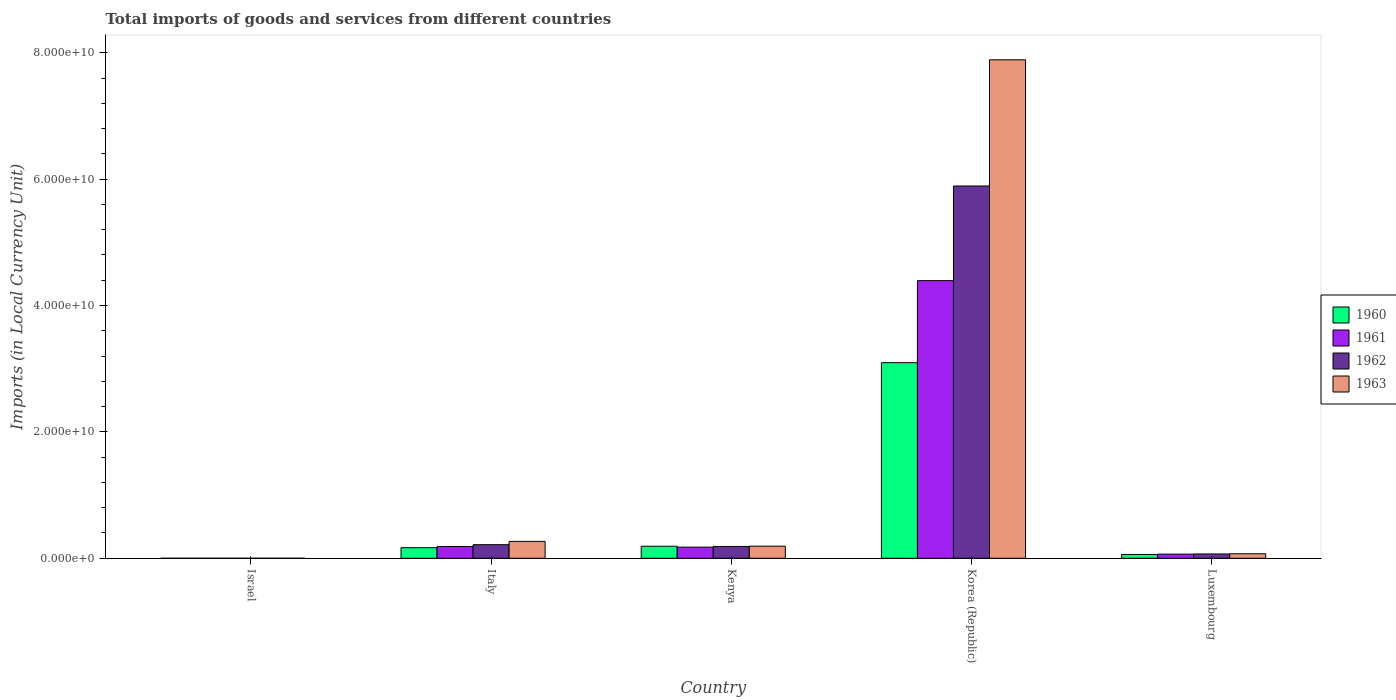How many different coloured bars are there?
Offer a terse response. 4. How many groups of bars are there?
Ensure brevity in your answer.  5. Are the number of bars on each tick of the X-axis equal?
Provide a succinct answer. Yes. How many bars are there on the 2nd tick from the left?
Give a very brief answer. 4. What is the label of the 1st group of bars from the left?
Provide a succinct answer. Israel. In how many cases, is the number of bars for a given country not equal to the number of legend labels?
Offer a terse response. 0. What is the Amount of goods and services imports in 1963 in Korea (Republic)?
Offer a very short reply. 7.89e+1. Across all countries, what is the maximum Amount of goods and services imports in 1961?
Offer a terse response. 4.39e+1. Across all countries, what is the minimum Amount of goods and services imports in 1962?
Give a very brief answer. 1.26e+05. What is the total Amount of goods and services imports in 1963 in the graph?
Keep it short and to the point. 8.42e+1. What is the difference between the Amount of goods and services imports in 1960 in Israel and that in Luxembourg?
Your answer should be compact. -6.02e+08. What is the difference between the Amount of goods and services imports in 1962 in Israel and the Amount of goods and services imports in 1960 in Kenya?
Your answer should be very brief. -1.90e+09. What is the average Amount of goods and services imports in 1960 per country?
Your response must be concise. 7.03e+09. What is the difference between the Amount of goods and services imports of/in 1960 and Amount of goods and services imports of/in 1961 in Luxembourg?
Give a very brief answer. -5.35e+07. In how many countries, is the Amount of goods and services imports in 1961 greater than 56000000000 LCU?
Give a very brief answer. 0. What is the ratio of the Amount of goods and services imports in 1963 in Israel to that in Italy?
Your response must be concise. 5.378096034779869e-5. Is the Amount of goods and services imports in 1963 in Israel less than that in Kenya?
Give a very brief answer. Yes. What is the difference between the highest and the second highest Amount of goods and services imports in 1960?
Offer a terse response. -2.93e+1. What is the difference between the highest and the lowest Amount of goods and services imports in 1961?
Make the answer very short. 4.39e+1. Is the sum of the Amount of goods and services imports in 1962 in Israel and Luxembourg greater than the maximum Amount of goods and services imports in 1963 across all countries?
Your answer should be very brief. No. What does the 2nd bar from the left in Italy represents?
Your answer should be very brief. 1961. What does the 3rd bar from the right in Luxembourg represents?
Provide a short and direct response. 1961. Is it the case that in every country, the sum of the Amount of goods and services imports in 1961 and Amount of goods and services imports in 1963 is greater than the Amount of goods and services imports in 1960?
Ensure brevity in your answer.  Yes. How many bars are there?
Give a very brief answer. 20. Are all the bars in the graph horizontal?
Provide a short and direct response. No. How many countries are there in the graph?
Provide a succinct answer. 5. Does the graph contain any zero values?
Provide a short and direct response. No. Where does the legend appear in the graph?
Ensure brevity in your answer.  Center right. How are the legend labels stacked?
Your response must be concise. Vertical. What is the title of the graph?
Ensure brevity in your answer.  Total imports of goods and services from different countries. What is the label or title of the X-axis?
Your response must be concise. Country. What is the label or title of the Y-axis?
Give a very brief answer. Imports (in Local Currency Unit). What is the Imports (in Local Currency Unit) of 1960 in Israel?
Provide a succinct answer. 5.78e+04. What is the Imports (in Local Currency Unit) in 1961 in Israel?
Your response must be concise. 7.04e+04. What is the Imports (in Local Currency Unit) in 1962 in Israel?
Offer a terse response. 1.26e+05. What is the Imports (in Local Currency Unit) in 1963 in Israel?
Ensure brevity in your answer.  1.44e+05. What is the Imports (in Local Currency Unit) in 1960 in Italy?
Your answer should be very brief. 1.67e+09. What is the Imports (in Local Currency Unit) of 1961 in Italy?
Your answer should be compact. 1.86e+09. What is the Imports (in Local Currency Unit) in 1962 in Italy?
Offer a very short reply. 2.15e+09. What is the Imports (in Local Currency Unit) in 1963 in Italy?
Provide a short and direct response. 2.67e+09. What is the Imports (in Local Currency Unit) of 1960 in Kenya?
Provide a succinct answer. 1.90e+09. What is the Imports (in Local Currency Unit) of 1961 in Kenya?
Provide a succinct answer. 1.76e+09. What is the Imports (in Local Currency Unit) in 1962 in Kenya?
Provide a short and direct response. 1.87e+09. What is the Imports (in Local Currency Unit) of 1963 in Kenya?
Provide a short and direct response. 1.92e+09. What is the Imports (in Local Currency Unit) in 1960 in Korea (Republic)?
Ensure brevity in your answer.  3.10e+1. What is the Imports (in Local Currency Unit) in 1961 in Korea (Republic)?
Offer a very short reply. 4.39e+1. What is the Imports (in Local Currency Unit) in 1962 in Korea (Republic)?
Your answer should be compact. 5.89e+1. What is the Imports (in Local Currency Unit) of 1963 in Korea (Republic)?
Provide a succinct answer. 7.89e+1. What is the Imports (in Local Currency Unit) of 1960 in Luxembourg?
Make the answer very short. 6.02e+08. What is the Imports (in Local Currency Unit) in 1961 in Luxembourg?
Your answer should be compact. 6.56e+08. What is the Imports (in Local Currency Unit) in 1962 in Luxembourg?
Make the answer very short. 6.82e+08. What is the Imports (in Local Currency Unit) of 1963 in Luxembourg?
Provide a succinct answer. 7.12e+08. Across all countries, what is the maximum Imports (in Local Currency Unit) of 1960?
Give a very brief answer. 3.10e+1. Across all countries, what is the maximum Imports (in Local Currency Unit) of 1961?
Make the answer very short. 4.39e+1. Across all countries, what is the maximum Imports (in Local Currency Unit) in 1962?
Keep it short and to the point. 5.89e+1. Across all countries, what is the maximum Imports (in Local Currency Unit) of 1963?
Ensure brevity in your answer.  7.89e+1. Across all countries, what is the minimum Imports (in Local Currency Unit) of 1960?
Offer a very short reply. 5.78e+04. Across all countries, what is the minimum Imports (in Local Currency Unit) in 1961?
Keep it short and to the point. 7.04e+04. Across all countries, what is the minimum Imports (in Local Currency Unit) in 1962?
Keep it short and to the point. 1.26e+05. Across all countries, what is the minimum Imports (in Local Currency Unit) of 1963?
Provide a short and direct response. 1.44e+05. What is the total Imports (in Local Currency Unit) in 1960 in the graph?
Your answer should be very brief. 3.51e+1. What is the total Imports (in Local Currency Unit) in 1961 in the graph?
Give a very brief answer. 4.82e+1. What is the total Imports (in Local Currency Unit) of 1962 in the graph?
Your answer should be very brief. 6.36e+1. What is the total Imports (in Local Currency Unit) of 1963 in the graph?
Make the answer very short. 8.42e+1. What is the difference between the Imports (in Local Currency Unit) of 1960 in Israel and that in Italy?
Your response must be concise. -1.67e+09. What is the difference between the Imports (in Local Currency Unit) in 1961 in Israel and that in Italy?
Your answer should be very brief. -1.86e+09. What is the difference between the Imports (in Local Currency Unit) of 1962 in Israel and that in Italy?
Give a very brief answer. -2.15e+09. What is the difference between the Imports (in Local Currency Unit) of 1963 in Israel and that in Italy?
Offer a terse response. -2.67e+09. What is the difference between the Imports (in Local Currency Unit) of 1960 in Israel and that in Kenya?
Offer a terse response. -1.90e+09. What is the difference between the Imports (in Local Currency Unit) of 1961 in Israel and that in Kenya?
Provide a succinct answer. -1.76e+09. What is the difference between the Imports (in Local Currency Unit) in 1962 in Israel and that in Kenya?
Offer a very short reply. -1.87e+09. What is the difference between the Imports (in Local Currency Unit) of 1963 in Israel and that in Kenya?
Provide a short and direct response. -1.92e+09. What is the difference between the Imports (in Local Currency Unit) in 1960 in Israel and that in Korea (Republic)?
Give a very brief answer. -3.10e+1. What is the difference between the Imports (in Local Currency Unit) of 1961 in Israel and that in Korea (Republic)?
Your answer should be compact. -4.39e+1. What is the difference between the Imports (in Local Currency Unit) of 1962 in Israel and that in Korea (Republic)?
Your response must be concise. -5.89e+1. What is the difference between the Imports (in Local Currency Unit) of 1963 in Israel and that in Korea (Republic)?
Keep it short and to the point. -7.89e+1. What is the difference between the Imports (in Local Currency Unit) in 1960 in Israel and that in Luxembourg?
Your response must be concise. -6.02e+08. What is the difference between the Imports (in Local Currency Unit) of 1961 in Israel and that in Luxembourg?
Give a very brief answer. -6.56e+08. What is the difference between the Imports (in Local Currency Unit) in 1962 in Israel and that in Luxembourg?
Give a very brief answer. -6.82e+08. What is the difference between the Imports (in Local Currency Unit) in 1963 in Israel and that in Luxembourg?
Offer a terse response. -7.12e+08. What is the difference between the Imports (in Local Currency Unit) in 1960 in Italy and that in Kenya?
Offer a very short reply. -2.29e+08. What is the difference between the Imports (in Local Currency Unit) in 1961 in Italy and that in Kenya?
Make the answer very short. 9.87e+07. What is the difference between the Imports (in Local Currency Unit) of 1962 in Italy and that in Kenya?
Your answer should be compact. 2.80e+08. What is the difference between the Imports (in Local Currency Unit) of 1963 in Italy and that in Kenya?
Keep it short and to the point. 7.55e+08. What is the difference between the Imports (in Local Currency Unit) in 1960 in Italy and that in Korea (Republic)?
Provide a succinct answer. -2.93e+1. What is the difference between the Imports (in Local Currency Unit) in 1961 in Italy and that in Korea (Republic)?
Keep it short and to the point. -4.21e+1. What is the difference between the Imports (in Local Currency Unit) of 1962 in Italy and that in Korea (Republic)?
Your response must be concise. -5.68e+1. What is the difference between the Imports (in Local Currency Unit) in 1963 in Italy and that in Korea (Republic)?
Your response must be concise. -7.62e+1. What is the difference between the Imports (in Local Currency Unit) of 1960 in Italy and that in Luxembourg?
Ensure brevity in your answer.  1.07e+09. What is the difference between the Imports (in Local Currency Unit) of 1961 in Italy and that in Luxembourg?
Give a very brief answer. 1.21e+09. What is the difference between the Imports (in Local Currency Unit) of 1962 in Italy and that in Luxembourg?
Your response must be concise. 1.47e+09. What is the difference between the Imports (in Local Currency Unit) of 1963 in Italy and that in Luxembourg?
Ensure brevity in your answer.  1.96e+09. What is the difference between the Imports (in Local Currency Unit) in 1960 in Kenya and that in Korea (Republic)?
Ensure brevity in your answer.  -2.91e+1. What is the difference between the Imports (in Local Currency Unit) in 1961 in Kenya and that in Korea (Republic)?
Your response must be concise. -4.22e+1. What is the difference between the Imports (in Local Currency Unit) of 1962 in Kenya and that in Korea (Republic)?
Keep it short and to the point. -5.70e+1. What is the difference between the Imports (in Local Currency Unit) of 1963 in Kenya and that in Korea (Republic)?
Ensure brevity in your answer.  -7.70e+1. What is the difference between the Imports (in Local Currency Unit) in 1960 in Kenya and that in Luxembourg?
Your response must be concise. 1.30e+09. What is the difference between the Imports (in Local Currency Unit) in 1961 in Kenya and that in Luxembourg?
Keep it short and to the point. 1.11e+09. What is the difference between the Imports (in Local Currency Unit) of 1962 in Kenya and that in Luxembourg?
Offer a very short reply. 1.19e+09. What is the difference between the Imports (in Local Currency Unit) in 1963 in Kenya and that in Luxembourg?
Keep it short and to the point. 1.21e+09. What is the difference between the Imports (in Local Currency Unit) of 1960 in Korea (Republic) and that in Luxembourg?
Ensure brevity in your answer.  3.04e+1. What is the difference between the Imports (in Local Currency Unit) in 1961 in Korea (Republic) and that in Luxembourg?
Keep it short and to the point. 4.33e+1. What is the difference between the Imports (in Local Currency Unit) of 1962 in Korea (Republic) and that in Luxembourg?
Keep it short and to the point. 5.82e+1. What is the difference between the Imports (in Local Currency Unit) in 1963 in Korea (Republic) and that in Luxembourg?
Ensure brevity in your answer.  7.82e+1. What is the difference between the Imports (in Local Currency Unit) of 1960 in Israel and the Imports (in Local Currency Unit) of 1961 in Italy?
Keep it short and to the point. -1.86e+09. What is the difference between the Imports (in Local Currency Unit) of 1960 in Israel and the Imports (in Local Currency Unit) of 1962 in Italy?
Offer a terse response. -2.15e+09. What is the difference between the Imports (in Local Currency Unit) in 1960 in Israel and the Imports (in Local Currency Unit) in 1963 in Italy?
Provide a succinct answer. -2.67e+09. What is the difference between the Imports (in Local Currency Unit) in 1961 in Israel and the Imports (in Local Currency Unit) in 1962 in Italy?
Give a very brief answer. -2.15e+09. What is the difference between the Imports (in Local Currency Unit) in 1961 in Israel and the Imports (in Local Currency Unit) in 1963 in Italy?
Give a very brief answer. -2.67e+09. What is the difference between the Imports (in Local Currency Unit) of 1962 in Israel and the Imports (in Local Currency Unit) of 1963 in Italy?
Make the answer very short. -2.67e+09. What is the difference between the Imports (in Local Currency Unit) in 1960 in Israel and the Imports (in Local Currency Unit) in 1961 in Kenya?
Your answer should be compact. -1.76e+09. What is the difference between the Imports (in Local Currency Unit) of 1960 in Israel and the Imports (in Local Currency Unit) of 1962 in Kenya?
Ensure brevity in your answer.  -1.87e+09. What is the difference between the Imports (in Local Currency Unit) of 1960 in Israel and the Imports (in Local Currency Unit) of 1963 in Kenya?
Ensure brevity in your answer.  -1.92e+09. What is the difference between the Imports (in Local Currency Unit) of 1961 in Israel and the Imports (in Local Currency Unit) of 1962 in Kenya?
Keep it short and to the point. -1.87e+09. What is the difference between the Imports (in Local Currency Unit) in 1961 in Israel and the Imports (in Local Currency Unit) in 1963 in Kenya?
Offer a terse response. -1.92e+09. What is the difference between the Imports (in Local Currency Unit) in 1962 in Israel and the Imports (in Local Currency Unit) in 1963 in Kenya?
Offer a very short reply. -1.92e+09. What is the difference between the Imports (in Local Currency Unit) in 1960 in Israel and the Imports (in Local Currency Unit) in 1961 in Korea (Republic)?
Provide a succinct answer. -4.39e+1. What is the difference between the Imports (in Local Currency Unit) of 1960 in Israel and the Imports (in Local Currency Unit) of 1962 in Korea (Republic)?
Offer a terse response. -5.89e+1. What is the difference between the Imports (in Local Currency Unit) in 1960 in Israel and the Imports (in Local Currency Unit) in 1963 in Korea (Republic)?
Give a very brief answer. -7.89e+1. What is the difference between the Imports (in Local Currency Unit) of 1961 in Israel and the Imports (in Local Currency Unit) of 1962 in Korea (Republic)?
Ensure brevity in your answer.  -5.89e+1. What is the difference between the Imports (in Local Currency Unit) of 1961 in Israel and the Imports (in Local Currency Unit) of 1963 in Korea (Republic)?
Make the answer very short. -7.89e+1. What is the difference between the Imports (in Local Currency Unit) in 1962 in Israel and the Imports (in Local Currency Unit) in 1963 in Korea (Republic)?
Keep it short and to the point. -7.89e+1. What is the difference between the Imports (in Local Currency Unit) in 1960 in Israel and the Imports (in Local Currency Unit) in 1961 in Luxembourg?
Make the answer very short. -6.56e+08. What is the difference between the Imports (in Local Currency Unit) of 1960 in Israel and the Imports (in Local Currency Unit) of 1962 in Luxembourg?
Your answer should be compact. -6.82e+08. What is the difference between the Imports (in Local Currency Unit) in 1960 in Israel and the Imports (in Local Currency Unit) in 1963 in Luxembourg?
Ensure brevity in your answer.  -7.12e+08. What is the difference between the Imports (in Local Currency Unit) of 1961 in Israel and the Imports (in Local Currency Unit) of 1962 in Luxembourg?
Your answer should be compact. -6.82e+08. What is the difference between the Imports (in Local Currency Unit) in 1961 in Israel and the Imports (in Local Currency Unit) in 1963 in Luxembourg?
Keep it short and to the point. -7.12e+08. What is the difference between the Imports (in Local Currency Unit) in 1962 in Israel and the Imports (in Local Currency Unit) in 1963 in Luxembourg?
Your answer should be very brief. -7.12e+08. What is the difference between the Imports (in Local Currency Unit) of 1960 in Italy and the Imports (in Local Currency Unit) of 1961 in Kenya?
Your response must be concise. -8.91e+07. What is the difference between the Imports (in Local Currency Unit) in 1960 in Italy and the Imports (in Local Currency Unit) in 1962 in Kenya?
Offer a terse response. -1.94e+08. What is the difference between the Imports (in Local Currency Unit) in 1960 in Italy and the Imports (in Local Currency Unit) in 1963 in Kenya?
Give a very brief answer. -2.43e+08. What is the difference between the Imports (in Local Currency Unit) in 1961 in Italy and the Imports (in Local Currency Unit) in 1962 in Kenya?
Give a very brief answer. -6.13e+06. What is the difference between the Imports (in Local Currency Unit) in 1961 in Italy and the Imports (in Local Currency Unit) in 1963 in Kenya?
Your response must be concise. -5.50e+07. What is the difference between the Imports (in Local Currency Unit) of 1962 in Italy and the Imports (in Local Currency Unit) of 1963 in Kenya?
Offer a very short reply. 2.31e+08. What is the difference between the Imports (in Local Currency Unit) in 1960 in Italy and the Imports (in Local Currency Unit) in 1961 in Korea (Republic)?
Your response must be concise. -4.23e+1. What is the difference between the Imports (in Local Currency Unit) of 1960 in Italy and the Imports (in Local Currency Unit) of 1962 in Korea (Republic)?
Offer a terse response. -5.72e+1. What is the difference between the Imports (in Local Currency Unit) in 1960 in Italy and the Imports (in Local Currency Unit) in 1963 in Korea (Republic)?
Keep it short and to the point. -7.72e+1. What is the difference between the Imports (in Local Currency Unit) of 1961 in Italy and the Imports (in Local Currency Unit) of 1962 in Korea (Republic)?
Make the answer very short. -5.71e+1. What is the difference between the Imports (in Local Currency Unit) in 1961 in Italy and the Imports (in Local Currency Unit) in 1963 in Korea (Republic)?
Provide a short and direct response. -7.70e+1. What is the difference between the Imports (in Local Currency Unit) in 1962 in Italy and the Imports (in Local Currency Unit) in 1963 in Korea (Republic)?
Ensure brevity in your answer.  -7.67e+1. What is the difference between the Imports (in Local Currency Unit) of 1960 in Italy and the Imports (in Local Currency Unit) of 1961 in Luxembourg?
Ensure brevity in your answer.  1.02e+09. What is the difference between the Imports (in Local Currency Unit) in 1960 in Italy and the Imports (in Local Currency Unit) in 1962 in Luxembourg?
Offer a terse response. 9.92e+08. What is the difference between the Imports (in Local Currency Unit) in 1960 in Italy and the Imports (in Local Currency Unit) in 1963 in Luxembourg?
Offer a very short reply. 9.62e+08. What is the difference between the Imports (in Local Currency Unit) of 1961 in Italy and the Imports (in Local Currency Unit) of 1962 in Luxembourg?
Make the answer very short. 1.18e+09. What is the difference between the Imports (in Local Currency Unit) of 1961 in Italy and the Imports (in Local Currency Unit) of 1963 in Luxembourg?
Offer a very short reply. 1.15e+09. What is the difference between the Imports (in Local Currency Unit) of 1962 in Italy and the Imports (in Local Currency Unit) of 1963 in Luxembourg?
Give a very brief answer. 1.44e+09. What is the difference between the Imports (in Local Currency Unit) of 1960 in Kenya and the Imports (in Local Currency Unit) of 1961 in Korea (Republic)?
Your response must be concise. -4.20e+1. What is the difference between the Imports (in Local Currency Unit) of 1960 in Kenya and the Imports (in Local Currency Unit) of 1962 in Korea (Republic)?
Ensure brevity in your answer.  -5.70e+1. What is the difference between the Imports (in Local Currency Unit) of 1960 in Kenya and the Imports (in Local Currency Unit) of 1963 in Korea (Republic)?
Give a very brief answer. -7.70e+1. What is the difference between the Imports (in Local Currency Unit) of 1961 in Kenya and the Imports (in Local Currency Unit) of 1962 in Korea (Republic)?
Provide a succinct answer. -5.71e+1. What is the difference between the Imports (in Local Currency Unit) of 1961 in Kenya and the Imports (in Local Currency Unit) of 1963 in Korea (Republic)?
Keep it short and to the point. -7.71e+1. What is the difference between the Imports (in Local Currency Unit) of 1962 in Kenya and the Imports (in Local Currency Unit) of 1963 in Korea (Republic)?
Your answer should be compact. -7.70e+1. What is the difference between the Imports (in Local Currency Unit) of 1960 in Kenya and the Imports (in Local Currency Unit) of 1961 in Luxembourg?
Provide a short and direct response. 1.25e+09. What is the difference between the Imports (in Local Currency Unit) in 1960 in Kenya and the Imports (in Local Currency Unit) in 1962 in Luxembourg?
Give a very brief answer. 1.22e+09. What is the difference between the Imports (in Local Currency Unit) of 1960 in Kenya and the Imports (in Local Currency Unit) of 1963 in Luxembourg?
Make the answer very short. 1.19e+09. What is the difference between the Imports (in Local Currency Unit) in 1961 in Kenya and the Imports (in Local Currency Unit) in 1962 in Luxembourg?
Offer a very short reply. 1.08e+09. What is the difference between the Imports (in Local Currency Unit) in 1961 in Kenya and the Imports (in Local Currency Unit) in 1963 in Luxembourg?
Your response must be concise. 1.05e+09. What is the difference between the Imports (in Local Currency Unit) in 1962 in Kenya and the Imports (in Local Currency Unit) in 1963 in Luxembourg?
Give a very brief answer. 1.16e+09. What is the difference between the Imports (in Local Currency Unit) of 1960 in Korea (Republic) and the Imports (in Local Currency Unit) of 1961 in Luxembourg?
Your answer should be very brief. 3.03e+1. What is the difference between the Imports (in Local Currency Unit) in 1960 in Korea (Republic) and the Imports (in Local Currency Unit) in 1962 in Luxembourg?
Make the answer very short. 3.03e+1. What is the difference between the Imports (in Local Currency Unit) of 1960 in Korea (Republic) and the Imports (in Local Currency Unit) of 1963 in Luxembourg?
Make the answer very short. 3.02e+1. What is the difference between the Imports (in Local Currency Unit) in 1961 in Korea (Republic) and the Imports (in Local Currency Unit) in 1962 in Luxembourg?
Provide a short and direct response. 4.33e+1. What is the difference between the Imports (in Local Currency Unit) in 1961 in Korea (Republic) and the Imports (in Local Currency Unit) in 1963 in Luxembourg?
Give a very brief answer. 4.32e+1. What is the difference between the Imports (in Local Currency Unit) in 1962 in Korea (Republic) and the Imports (in Local Currency Unit) in 1963 in Luxembourg?
Provide a short and direct response. 5.82e+1. What is the average Imports (in Local Currency Unit) in 1960 per country?
Your response must be concise. 7.03e+09. What is the average Imports (in Local Currency Unit) in 1961 per country?
Ensure brevity in your answer.  9.64e+09. What is the average Imports (in Local Currency Unit) in 1962 per country?
Give a very brief answer. 1.27e+1. What is the average Imports (in Local Currency Unit) in 1963 per country?
Provide a succinct answer. 1.68e+1. What is the difference between the Imports (in Local Currency Unit) in 1960 and Imports (in Local Currency Unit) in 1961 in Israel?
Your response must be concise. -1.26e+04. What is the difference between the Imports (in Local Currency Unit) of 1960 and Imports (in Local Currency Unit) of 1962 in Israel?
Offer a very short reply. -6.82e+04. What is the difference between the Imports (in Local Currency Unit) of 1960 and Imports (in Local Currency Unit) of 1963 in Israel?
Your answer should be compact. -8.59e+04. What is the difference between the Imports (in Local Currency Unit) in 1961 and Imports (in Local Currency Unit) in 1962 in Israel?
Offer a terse response. -5.56e+04. What is the difference between the Imports (in Local Currency Unit) in 1961 and Imports (in Local Currency Unit) in 1963 in Israel?
Provide a short and direct response. -7.33e+04. What is the difference between the Imports (in Local Currency Unit) of 1962 and Imports (in Local Currency Unit) of 1963 in Israel?
Your answer should be very brief. -1.77e+04. What is the difference between the Imports (in Local Currency Unit) in 1960 and Imports (in Local Currency Unit) in 1961 in Italy?
Provide a succinct answer. -1.88e+08. What is the difference between the Imports (in Local Currency Unit) in 1960 and Imports (in Local Currency Unit) in 1962 in Italy?
Ensure brevity in your answer.  -4.73e+08. What is the difference between the Imports (in Local Currency Unit) in 1960 and Imports (in Local Currency Unit) in 1963 in Italy?
Your answer should be very brief. -9.98e+08. What is the difference between the Imports (in Local Currency Unit) in 1961 and Imports (in Local Currency Unit) in 1962 in Italy?
Ensure brevity in your answer.  -2.86e+08. What is the difference between the Imports (in Local Currency Unit) of 1961 and Imports (in Local Currency Unit) of 1963 in Italy?
Give a very brief answer. -8.10e+08. What is the difference between the Imports (in Local Currency Unit) in 1962 and Imports (in Local Currency Unit) in 1963 in Italy?
Your answer should be compact. -5.24e+08. What is the difference between the Imports (in Local Currency Unit) of 1960 and Imports (in Local Currency Unit) of 1961 in Kenya?
Your answer should be very brief. 1.40e+08. What is the difference between the Imports (in Local Currency Unit) of 1960 and Imports (in Local Currency Unit) of 1962 in Kenya?
Ensure brevity in your answer.  3.50e+07. What is the difference between the Imports (in Local Currency Unit) of 1960 and Imports (in Local Currency Unit) of 1963 in Kenya?
Offer a very short reply. -1.39e+07. What is the difference between the Imports (in Local Currency Unit) in 1961 and Imports (in Local Currency Unit) in 1962 in Kenya?
Your answer should be very brief. -1.05e+08. What is the difference between the Imports (in Local Currency Unit) in 1961 and Imports (in Local Currency Unit) in 1963 in Kenya?
Your response must be concise. -1.54e+08. What is the difference between the Imports (in Local Currency Unit) of 1962 and Imports (in Local Currency Unit) of 1963 in Kenya?
Provide a succinct answer. -4.89e+07. What is the difference between the Imports (in Local Currency Unit) in 1960 and Imports (in Local Currency Unit) in 1961 in Korea (Republic)?
Provide a succinct answer. -1.30e+1. What is the difference between the Imports (in Local Currency Unit) in 1960 and Imports (in Local Currency Unit) in 1962 in Korea (Republic)?
Offer a terse response. -2.80e+1. What is the difference between the Imports (in Local Currency Unit) in 1960 and Imports (in Local Currency Unit) in 1963 in Korea (Republic)?
Keep it short and to the point. -4.79e+1. What is the difference between the Imports (in Local Currency Unit) of 1961 and Imports (in Local Currency Unit) of 1962 in Korea (Republic)?
Offer a terse response. -1.50e+1. What is the difference between the Imports (in Local Currency Unit) in 1961 and Imports (in Local Currency Unit) in 1963 in Korea (Republic)?
Give a very brief answer. -3.49e+1. What is the difference between the Imports (in Local Currency Unit) of 1962 and Imports (in Local Currency Unit) of 1963 in Korea (Republic)?
Offer a terse response. -2.00e+1. What is the difference between the Imports (in Local Currency Unit) of 1960 and Imports (in Local Currency Unit) of 1961 in Luxembourg?
Provide a succinct answer. -5.35e+07. What is the difference between the Imports (in Local Currency Unit) in 1960 and Imports (in Local Currency Unit) in 1962 in Luxembourg?
Provide a short and direct response. -7.95e+07. What is the difference between the Imports (in Local Currency Unit) of 1960 and Imports (in Local Currency Unit) of 1963 in Luxembourg?
Offer a terse response. -1.09e+08. What is the difference between the Imports (in Local Currency Unit) in 1961 and Imports (in Local Currency Unit) in 1962 in Luxembourg?
Provide a succinct answer. -2.61e+07. What is the difference between the Imports (in Local Currency Unit) of 1961 and Imports (in Local Currency Unit) of 1963 in Luxembourg?
Your answer should be very brief. -5.59e+07. What is the difference between the Imports (in Local Currency Unit) in 1962 and Imports (in Local Currency Unit) in 1963 in Luxembourg?
Ensure brevity in your answer.  -2.99e+07. What is the ratio of the Imports (in Local Currency Unit) in 1961 in Israel to that in Italy?
Offer a terse response. 0. What is the ratio of the Imports (in Local Currency Unit) in 1963 in Israel to that in Italy?
Ensure brevity in your answer.  0. What is the ratio of the Imports (in Local Currency Unit) of 1960 in Israel to that in Kenya?
Ensure brevity in your answer.  0. What is the ratio of the Imports (in Local Currency Unit) of 1962 in Israel to that in Kenya?
Provide a succinct answer. 0. What is the ratio of the Imports (in Local Currency Unit) in 1960 in Israel to that in Korea (Republic)?
Give a very brief answer. 0. What is the ratio of the Imports (in Local Currency Unit) of 1963 in Israel to that in Korea (Republic)?
Your response must be concise. 0. What is the ratio of the Imports (in Local Currency Unit) of 1963 in Israel to that in Luxembourg?
Provide a short and direct response. 0. What is the ratio of the Imports (in Local Currency Unit) in 1960 in Italy to that in Kenya?
Your response must be concise. 0.88. What is the ratio of the Imports (in Local Currency Unit) of 1961 in Italy to that in Kenya?
Provide a short and direct response. 1.06. What is the ratio of the Imports (in Local Currency Unit) of 1962 in Italy to that in Kenya?
Keep it short and to the point. 1.15. What is the ratio of the Imports (in Local Currency Unit) of 1963 in Italy to that in Kenya?
Your answer should be very brief. 1.39. What is the ratio of the Imports (in Local Currency Unit) in 1960 in Italy to that in Korea (Republic)?
Offer a very short reply. 0.05. What is the ratio of the Imports (in Local Currency Unit) of 1961 in Italy to that in Korea (Republic)?
Provide a short and direct response. 0.04. What is the ratio of the Imports (in Local Currency Unit) of 1962 in Italy to that in Korea (Republic)?
Ensure brevity in your answer.  0.04. What is the ratio of the Imports (in Local Currency Unit) of 1963 in Italy to that in Korea (Republic)?
Offer a very short reply. 0.03. What is the ratio of the Imports (in Local Currency Unit) of 1960 in Italy to that in Luxembourg?
Provide a succinct answer. 2.78. What is the ratio of the Imports (in Local Currency Unit) in 1961 in Italy to that in Luxembourg?
Your answer should be very brief. 2.84. What is the ratio of the Imports (in Local Currency Unit) in 1962 in Italy to that in Luxembourg?
Provide a succinct answer. 3.15. What is the ratio of the Imports (in Local Currency Unit) in 1963 in Italy to that in Luxembourg?
Ensure brevity in your answer.  3.75. What is the ratio of the Imports (in Local Currency Unit) of 1960 in Kenya to that in Korea (Republic)?
Offer a terse response. 0.06. What is the ratio of the Imports (in Local Currency Unit) of 1961 in Kenya to that in Korea (Republic)?
Make the answer very short. 0.04. What is the ratio of the Imports (in Local Currency Unit) in 1962 in Kenya to that in Korea (Republic)?
Offer a terse response. 0.03. What is the ratio of the Imports (in Local Currency Unit) in 1963 in Kenya to that in Korea (Republic)?
Make the answer very short. 0.02. What is the ratio of the Imports (in Local Currency Unit) in 1960 in Kenya to that in Luxembourg?
Give a very brief answer. 3.16. What is the ratio of the Imports (in Local Currency Unit) in 1961 in Kenya to that in Luxembourg?
Your response must be concise. 2.69. What is the ratio of the Imports (in Local Currency Unit) in 1962 in Kenya to that in Luxembourg?
Provide a short and direct response. 2.74. What is the ratio of the Imports (in Local Currency Unit) in 1963 in Kenya to that in Luxembourg?
Offer a terse response. 2.69. What is the ratio of the Imports (in Local Currency Unit) of 1960 in Korea (Republic) to that in Luxembourg?
Your response must be concise. 51.39. What is the ratio of the Imports (in Local Currency Unit) in 1961 in Korea (Republic) to that in Luxembourg?
Give a very brief answer. 66.99. What is the ratio of the Imports (in Local Currency Unit) in 1962 in Korea (Republic) to that in Luxembourg?
Make the answer very short. 86.4. What is the ratio of the Imports (in Local Currency Unit) in 1963 in Korea (Republic) to that in Luxembourg?
Your response must be concise. 110.83. What is the difference between the highest and the second highest Imports (in Local Currency Unit) of 1960?
Keep it short and to the point. 2.91e+1. What is the difference between the highest and the second highest Imports (in Local Currency Unit) of 1961?
Ensure brevity in your answer.  4.21e+1. What is the difference between the highest and the second highest Imports (in Local Currency Unit) in 1962?
Make the answer very short. 5.68e+1. What is the difference between the highest and the second highest Imports (in Local Currency Unit) of 1963?
Make the answer very short. 7.62e+1. What is the difference between the highest and the lowest Imports (in Local Currency Unit) in 1960?
Your response must be concise. 3.10e+1. What is the difference between the highest and the lowest Imports (in Local Currency Unit) of 1961?
Your response must be concise. 4.39e+1. What is the difference between the highest and the lowest Imports (in Local Currency Unit) in 1962?
Provide a short and direct response. 5.89e+1. What is the difference between the highest and the lowest Imports (in Local Currency Unit) in 1963?
Ensure brevity in your answer.  7.89e+1. 